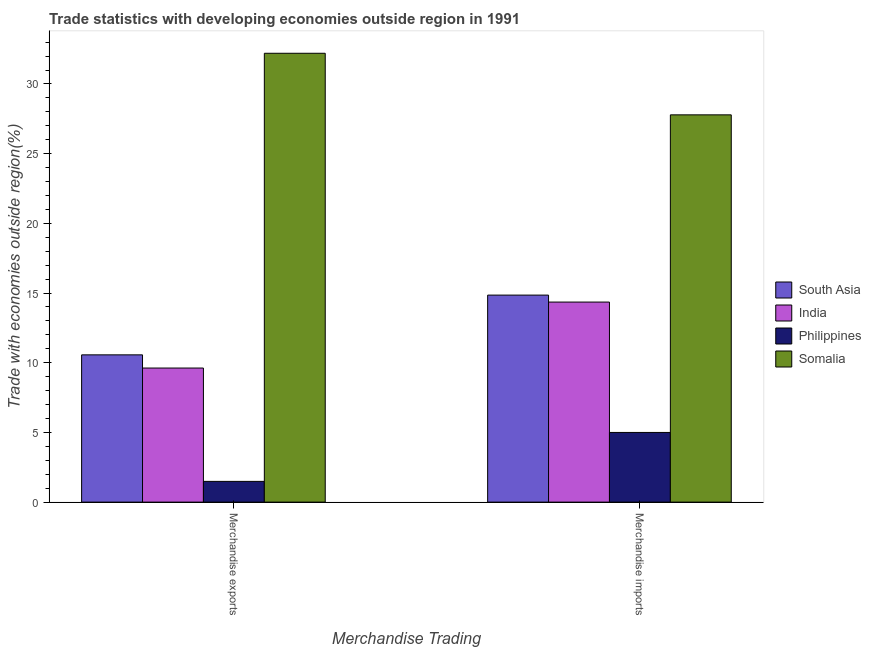How many groups of bars are there?
Offer a very short reply. 2. How many bars are there on the 1st tick from the left?
Keep it short and to the point. 4. What is the label of the 1st group of bars from the left?
Give a very brief answer. Merchandise exports. What is the merchandise exports in India?
Provide a short and direct response. 9.62. Across all countries, what is the maximum merchandise imports?
Your answer should be compact. 27.78. Across all countries, what is the minimum merchandise imports?
Provide a succinct answer. 5. In which country was the merchandise exports maximum?
Ensure brevity in your answer.  Somalia. In which country was the merchandise imports minimum?
Keep it short and to the point. Philippines. What is the total merchandise imports in the graph?
Keep it short and to the point. 61.99. What is the difference between the merchandise exports in South Asia and that in Somalia?
Ensure brevity in your answer.  -21.64. What is the difference between the merchandise exports in South Asia and the merchandise imports in Somalia?
Provide a succinct answer. -17.22. What is the average merchandise imports per country?
Your answer should be compact. 15.5. What is the difference between the merchandise exports and merchandise imports in Philippines?
Your response must be concise. -3.51. In how many countries, is the merchandise imports greater than 5 %?
Offer a terse response. 3. What is the ratio of the merchandise imports in Somalia to that in Philippines?
Make the answer very short. 5.56. In how many countries, is the merchandise imports greater than the average merchandise imports taken over all countries?
Your answer should be very brief. 1. What does the 2nd bar from the left in Merchandise imports represents?
Provide a short and direct response. India. How many bars are there?
Offer a terse response. 8. How many countries are there in the graph?
Offer a terse response. 4. What is the difference between two consecutive major ticks on the Y-axis?
Offer a terse response. 5. Are the values on the major ticks of Y-axis written in scientific E-notation?
Your response must be concise. No. How are the legend labels stacked?
Offer a terse response. Vertical. What is the title of the graph?
Offer a terse response. Trade statistics with developing economies outside region in 1991. What is the label or title of the X-axis?
Your response must be concise. Merchandise Trading. What is the label or title of the Y-axis?
Provide a short and direct response. Trade with economies outside region(%). What is the Trade with economies outside region(%) in South Asia in Merchandise exports?
Offer a terse response. 10.57. What is the Trade with economies outside region(%) of India in Merchandise exports?
Your answer should be very brief. 9.62. What is the Trade with economies outside region(%) of Philippines in Merchandise exports?
Ensure brevity in your answer.  1.49. What is the Trade with economies outside region(%) in Somalia in Merchandise exports?
Keep it short and to the point. 32.2. What is the Trade with economies outside region(%) in South Asia in Merchandise imports?
Your answer should be very brief. 14.85. What is the Trade with economies outside region(%) in India in Merchandise imports?
Offer a very short reply. 14.35. What is the Trade with economies outside region(%) in Philippines in Merchandise imports?
Provide a succinct answer. 5. What is the Trade with economies outside region(%) in Somalia in Merchandise imports?
Offer a terse response. 27.78. Across all Merchandise Trading, what is the maximum Trade with economies outside region(%) in South Asia?
Keep it short and to the point. 14.85. Across all Merchandise Trading, what is the maximum Trade with economies outside region(%) of India?
Your answer should be very brief. 14.35. Across all Merchandise Trading, what is the maximum Trade with economies outside region(%) of Philippines?
Your answer should be very brief. 5. Across all Merchandise Trading, what is the maximum Trade with economies outside region(%) in Somalia?
Provide a short and direct response. 32.2. Across all Merchandise Trading, what is the minimum Trade with economies outside region(%) of South Asia?
Make the answer very short. 10.57. Across all Merchandise Trading, what is the minimum Trade with economies outside region(%) in India?
Provide a succinct answer. 9.62. Across all Merchandise Trading, what is the minimum Trade with economies outside region(%) in Philippines?
Provide a succinct answer. 1.49. Across all Merchandise Trading, what is the minimum Trade with economies outside region(%) in Somalia?
Provide a succinct answer. 27.78. What is the total Trade with economies outside region(%) of South Asia in the graph?
Your answer should be very brief. 25.42. What is the total Trade with economies outside region(%) in India in the graph?
Provide a succinct answer. 23.97. What is the total Trade with economies outside region(%) in Philippines in the graph?
Ensure brevity in your answer.  6.49. What is the total Trade with economies outside region(%) of Somalia in the graph?
Provide a succinct answer. 59.98. What is the difference between the Trade with economies outside region(%) of South Asia in Merchandise exports and that in Merchandise imports?
Offer a terse response. -4.29. What is the difference between the Trade with economies outside region(%) of India in Merchandise exports and that in Merchandise imports?
Ensure brevity in your answer.  -4.73. What is the difference between the Trade with economies outside region(%) of Philippines in Merchandise exports and that in Merchandise imports?
Your response must be concise. -3.51. What is the difference between the Trade with economies outside region(%) of Somalia in Merchandise exports and that in Merchandise imports?
Make the answer very short. 4.42. What is the difference between the Trade with economies outside region(%) of South Asia in Merchandise exports and the Trade with economies outside region(%) of India in Merchandise imports?
Offer a terse response. -3.79. What is the difference between the Trade with economies outside region(%) of South Asia in Merchandise exports and the Trade with economies outside region(%) of Philippines in Merchandise imports?
Your answer should be very brief. 5.57. What is the difference between the Trade with economies outside region(%) in South Asia in Merchandise exports and the Trade with economies outside region(%) in Somalia in Merchandise imports?
Provide a short and direct response. -17.22. What is the difference between the Trade with economies outside region(%) of India in Merchandise exports and the Trade with economies outside region(%) of Philippines in Merchandise imports?
Keep it short and to the point. 4.62. What is the difference between the Trade with economies outside region(%) of India in Merchandise exports and the Trade with economies outside region(%) of Somalia in Merchandise imports?
Make the answer very short. -18.16. What is the difference between the Trade with economies outside region(%) of Philippines in Merchandise exports and the Trade with economies outside region(%) of Somalia in Merchandise imports?
Your answer should be very brief. -26.3. What is the average Trade with economies outside region(%) of South Asia per Merchandise Trading?
Your answer should be very brief. 12.71. What is the average Trade with economies outside region(%) of India per Merchandise Trading?
Ensure brevity in your answer.  11.99. What is the average Trade with economies outside region(%) of Philippines per Merchandise Trading?
Offer a very short reply. 3.24. What is the average Trade with economies outside region(%) of Somalia per Merchandise Trading?
Make the answer very short. 29.99. What is the difference between the Trade with economies outside region(%) in South Asia and Trade with economies outside region(%) in India in Merchandise exports?
Keep it short and to the point. 0.95. What is the difference between the Trade with economies outside region(%) in South Asia and Trade with economies outside region(%) in Philippines in Merchandise exports?
Provide a short and direct response. 9.08. What is the difference between the Trade with economies outside region(%) of South Asia and Trade with economies outside region(%) of Somalia in Merchandise exports?
Offer a very short reply. -21.64. What is the difference between the Trade with economies outside region(%) of India and Trade with economies outside region(%) of Philippines in Merchandise exports?
Offer a very short reply. 8.13. What is the difference between the Trade with economies outside region(%) in India and Trade with economies outside region(%) in Somalia in Merchandise exports?
Give a very brief answer. -22.58. What is the difference between the Trade with economies outside region(%) in Philippines and Trade with economies outside region(%) in Somalia in Merchandise exports?
Offer a terse response. -30.71. What is the difference between the Trade with economies outside region(%) of South Asia and Trade with economies outside region(%) of India in Merchandise imports?
Your answer should be very brief. 0.5. What is the difference between the Trade with economies outside region(%) in South Asia and Trade with economies outside region(%) in Philippines in Merchandise imports?
Provide a succinct answer. 9.85. What is the difference between the Trade with economies outside region(%) of South Asia and Trade with economies outside region(%) of Somalia in Merchandise imports?
Offer a terse response. -12.93. What is the difference between the Trade with economies outside region(%) in India and Trade with economies outside region(%) in Philippines in Merchandise imports?
Give a very brief answer. 9.35. What is the difference between the Trade with economies outside region(%) in India and Trade with economies outside region(%) in Somalia in Merchandise imports?
Offer a terse response. -13.43. What is the difference between the Trade with economies outside region(%) in Philippines and Trade with economies outside region(%) in Somalia in Merchandise imports?
Your answer should be compact. -22.79. What is the ratio of the Trade with economies outside region(%) in South Asia in Merchandise exports to that in Merchandise imports?
Keep it short and to the point. 0.71. What is the ratio of the Trade with economies outside region(%) in India in Merchandise exports to that in Merchandise imports?
Ensure brevity in your answer.  0.67. What is the ratio of the Trade with economies outside region(%) in Philippines in Merchandise exports to that in Merchandise imports?
Offer a terse response. 0.3. What is the ratio of the Trade with economies outside region(%) of Somalia in Merchandise exports to that in Merchandise imports?
Your response must be concise. 1.16. What is the difference between the highest and the second highest Trade with economies outside region(%) in South Asia?
Ensure brevity in your answer.  4.29. What is the difference between the highest and the second highest Trade with economies outside region(%) of India?
Give a very brief answer. 4.73. What is the difference between the highest and the second highest Trade with economies outside region(%) of Philippines?
Offer a terse response. 3.51. What is the difference between the highest and the second highest Trade with economies outside region(%) in Somalia?
Keep it short and to the point. 4.42. What is the difference between the highest and the lowest Trade with economies outside region(%) of South Asia?
Make the answer very short. 4.29. What is the difference between the highest and the lowest Trade with economies outside region(%) of India?
Keep it short and to the point. 4.73. What is the difference between the highest and the lowest Trade with economies outside region(%) of Philippines?
Make the answer very short. 3.51. What is the difference between the highest and the lowest Trade with economies outside region(%) of Somalia?
Offer a very short reply. 4.42. 